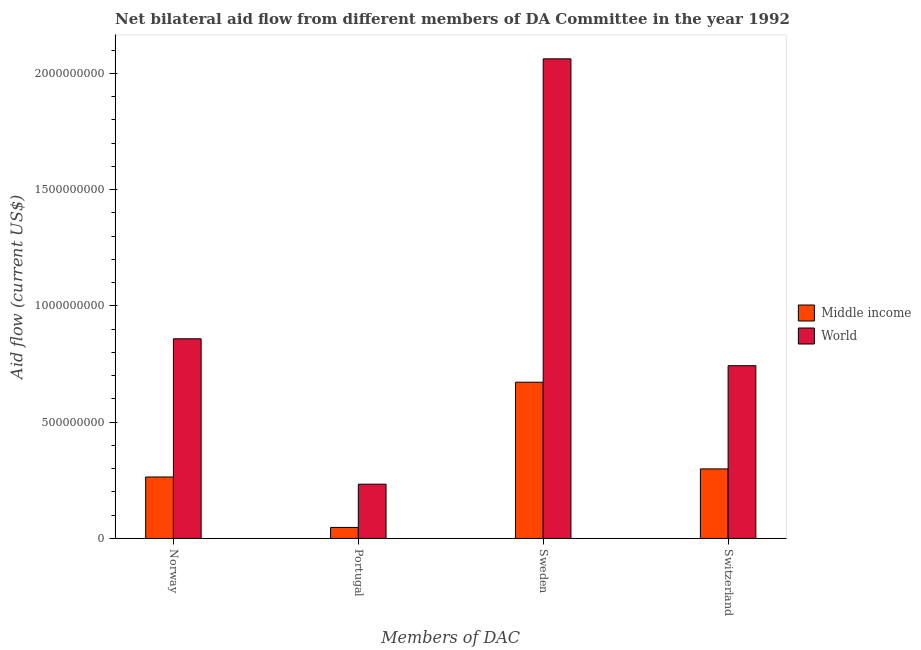Are the number of bars on each tick of the X-axis equal?
Your response must be concise. Yes. How many bars are there on the 1st tick from the left?
Keep it short and to the point. 2. What is the amount of aid given by switzerland in Middle income?
Provide a short and direct response. 2.99e+08. Across all countries, what is the maximum amount of aid given by norway?
Offer a terse response. 8.58e+08. Across all countries, what is the minimum amount of aid given by sweden?
Your answer should be compact. 6.72e+08. In which country was the amount of aid given by portugal minimum?
Offer a very short reply. Middle income. What is the total amount of aid given by switzerland in the graph?
Provide a short and direct response. 1.04e+09. What is the difference between the amount of aid given by sweden in Middle income and that in World?
Offer a terse response. -1.39e+09. What is the difference between the amount of aid given by switzerland in World and the amount of aid given by norway in Middle income?
Offer a terse response. 4.79e+08. What is the average amount of aid given by sweden per country?
Your response must be concise. 1.37e+09. What is the difference between the amount of aid given by portugal and amount of aid given by norway in World?
Your answer should be very brief. -6.25e+08. In how many countries, is the amount of aid given by switzerland greater than 2000000000 US$?
Keep it short and to the point. 0. What is the ratio of the amount of aid given by sweden in Middle income to that in World?
Provide a succinct answer. 0.33. Is the amount of aid given by switzerland in World less than that in Middle income?
Your response must be concise. No. Is the difference between the amount of aid given by sweden in Middle income and World greater than the difference between the amount of aid given by norway in Middle income and World?
Keep it short and to the point. No. What is the difference between the highest and the second highest amount of aid given by switzerland?
Provide a short and direct response. 4.44e+08. What is the difference between the highest and the lowest amount of aid given by switzerland?
Offer a very short reply. 4.44e+08. In how many countries, is the amount of aid given by sweden greater than the average amount of aid given by sweden taken over all countries?
Offer a terse response. 1. Is the sum of the amount of aid given by norway in World and Middle income greater than the maximum amount of aid given by switzerland across all countries?
Ensure brevity in your answer.  Yes. What does the 1st bar from the right in Portugal represents?
Provide a succinct answer. World. How many bars are there?
Ensure brevity in your answer.  8. How many countries are there in the graph?
Make the answer very short. 2. What is the difference between two consecutive major ticks on the Y-axis?
Give a very brief answer. 5.00e+08. Does the graph contain grids?
Your answer should be compact. No. Where does the legend appear in the graph?
Provide a succinct answer. Center right. How many legend labels are there?
Provide a succinct answer. 2. What is the title of the graph?
Your answer should be very brief. Net bilateral aid flow from different members of DA Committee in the year 1992. Does "Senegal" appear as one of the legend labels in the graph?
Your answer should be compact. No. What is the label or title of the X-axis?
Keep it short and to the point. Members of DAC. What is the label or title of the Y-axis?
Your answer should be very brief. Aid flow (current US$). What is the Aid flow (current US$) in Middle income in Norway?
Provide a short and direct response. 2.64e+08. What is the Aid flow (current US$) of World in Norway?
Offer a terse response. 8.58e+08. What is the Aid flow (current US$) in Middle income in Portugal?
Offer a very short reply. 4.73e+07. What is the Aid flow (current US$) in World in Portugal?
Provide a short and direct response. 2.33e+08. What is the Aid flow (current US$) in Middle income in Sweden?
Give a very brief answer. 6.72e+08. What is the Aid flow (current US$) of World in Sweden?
Your answer should be very brief. 2.06e+09. What is the Aid flow (current US$) of Middle income in Switzerland?
Offer a very short reply. 2.99e+08. What is the Aid flow (current US$) of World in Switzerland?
Ensure brevity in your answer.  7.43e+08. Across all Members of DAC, what is the maximum Aid flow (current US$) of Middle income?
Ensure brevity in your answer.  6.72e+08. Across all Members of DAC, what is the maximum Aid flow (current US$) in World?
Provide a short and direct response. 2.06e+09. Across all Members of DAC, what is the minimum Aid flow (current US$) in Middle income?
Keep it short and to the point. 4.73e+07. Across all Members of DAC, what is the minimum Aid flow (current US$) in World?
Make the answer very short. 2.33e+08. What is the total Aid flow (current US$) of Middle income in the graph?
Your response must be concise. 1.28e+09. What is the total Aid flow (current US$) in World in the graph?
Provide a short and direct response. 3.90e+09. What is the difference between the Aid flow (current US$) in Middle income in Norway and that in Portugal?
Your response must be concise. 2.17e+08. What is the difference between the Aid flow (current US$) in World in Norway and that in Portugal?
Your response must be concise. 6.25e+08. What is the difference between the Aid flow (current US$) in Middle income in Norway and that in Sweden?
Your answer should be very brief. -4.08e+08. What is the difference between the Aid flow (current US$) of World in Norway and that in Sweden?
Ensure brevity in your answer.  -1.20e+09. What is the difference between the Aid flow (current US$) of Middle income in Norway and that in Switzerland?
Keep it short and to the point. -3.48e+07. What is the difference between the Aid flow (current US$) in World in Norway and that in Switzerland?
Give a very brief answer. 1.16e+08. What is the difference between the Aid flow (current US$) in Middle income in Portugal and that in Sweden?
Your response must be concise. -6.24e+08. What is the difference between the Aid flow (current US$) in World in Portugal and that in Sweden?
Offer a very short reply. -1.83e+09. What is the difference between the Aid flow (current US$) of Middle income in Portugal and that in Switzerland?
Give a very brief answer. -2.52e+08. What is the difference between the Aid flow (current US$) of World in Portugal and that in Switzerland?
Provide a succinct answer. -5.09e+08. What is the difference between the Aid flow (current US$) of Middle income in Sweden and that in Switzerland?
Provide a succinct answer. 3.73e+08. What is the difference between the Aid flow (current US$) of World in Sweden and that in Switzerland?
Offer a very short reply. 1.32e+09. What is the difference between the Aid flow (current US$) in Middle income in Norway and the Aid flow (current US$) in World in Portugal?
Your answer should be very brief. 3.09e+07. What is the difference between the Aid flow (current US$) in Middle income in Norway and the Aid flow (current US$) in World in Sweden?
Offer a terse response. -1.80e+09. What is the difference between the Aid flow (current US$) of Middle income in Norway and the Aid flow (current US$) of World in Switzerland?
Your answer should be compact. -4.79e+08. What is the difference between the Aid flow (current US$) in Middle income in Portugal and the Aid flow (current US$) in World in Sweden?
Provide a short and direct response. -2.01e+09. What is the difference between the Aid flow (current US$) in Middle income in Portugal and the Aid flow (current US$) in World in Switzerland?
Ensure brevity in your answer.  -6.95e+08. What is the difference between the Aid flow (current US$) of Middle income in Sweden and the Aid flow (current US$) of World in Switzerland?
Make the answer very short. -7.10e+07. What is the average Aid flow (current US$) in Middle income per Members of DAC?
Make the answer very short. 3.21e+08. What is the average Aid flow (current US$) in World per Members of DAC?
Make the answer very short. 9.74e+08. What is the difference between the Aid flow (current US$) in Middle income and Aid flow (current US$) in World in Norway?
Offer a very short reply. -5.94e+08. What is the difference between the Aid flow (current US$) of Middle income and Aid flow (current US$) of World in Portugal?
Keep it short and to the point. -1.86e+08. What is the difference between the Aid flow (current US$) of Middle income and Aid flow (current US$) of World in Sweden?
Offer a very short reply. -1.39e+09. What is the difference between the Aid flow (current US$) in Middle income and Aid flow (current US$) in World in Switzerland?
Offer a terse response. -4.44e+08. What is the ratio of the Aid flow (current US$) of Middle income in Norway to that in Portugal?
Your answer should be compact. 5.58. What is the ratio of the Aid flow (current US$) of World in Norway to that in Portugal?
Your response must be concise. 3.68. What is the ratio of the Aid flow (current US$) in Middle income in Norway to that in Sweden?
Give a very brief answer. 0.39. What is the ratio of the Aid flow (current US$) in World in Norway to that in Sweden?
Offer a very short reply. 0.42. What is the ratio of the Aid flow (current US$) of Middle income in Norway to that in Switzerland?
Your response must be concise. 0.88. What is the ratio of the Aid flow (current US$) of World in Norway to that in Switzerland?
Provide a succinct answer. 1.16. What is the ratio of the Aid flow (current US$) of Middle income in Portugal to that in Sweden?
Ensure brevity in your answer.  0.07. What is the ratio of the Aid flow (current US$) of World in Portugal to that in Sweden?
Keep it short and to the point. 0.11. What is the ratio of the Aid flow (current US$) in Middle income in Portugal to that in Switzerland?
Your response must be concise. 0.16. What is the ratio of the Aid flow (current US$) of World in Portugal to that in Switzerland?
Your response must be concise. 0.31. What is the ratio of the Aid flow (current US$) in Middle income in Sweden to that in Switzerland?
Offer a terse response. 2.25. What is the ratio of the Aid flow (current US$) in World in Sweden to that in Switzerland?
Offer a very short reply. 2.78. What is the difference between the highest and the second highest Aid flow (current US$) of Middle income?
Your response must be concise. 3.73e+08. What is the difference between the highest and the second highest Aid flow (current US$) of World?
Give a very brief answer. 1.20e+09. What is the difference between the highest and the lowest Aid flow (current US$) in Middle income?
Offer a very short reply. 6.24e+08. What is the difference between the highest and the lowest Aid flow (current US$) in World?
Provide a succinct answer. 1.83e+09. 